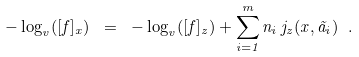<formula> <loc_0><loc_0><loc_500><loc_500>- \log _ { v } ( [ f ] _ { x } ) \ = \ - \log _ { v } ( [ f ] _ { z } ) + \sum _ { i = 1 } ^ { m } n _ { i } \, j _ { z } ( x , \tilde { a } _ { i } ) \ .</formula> 